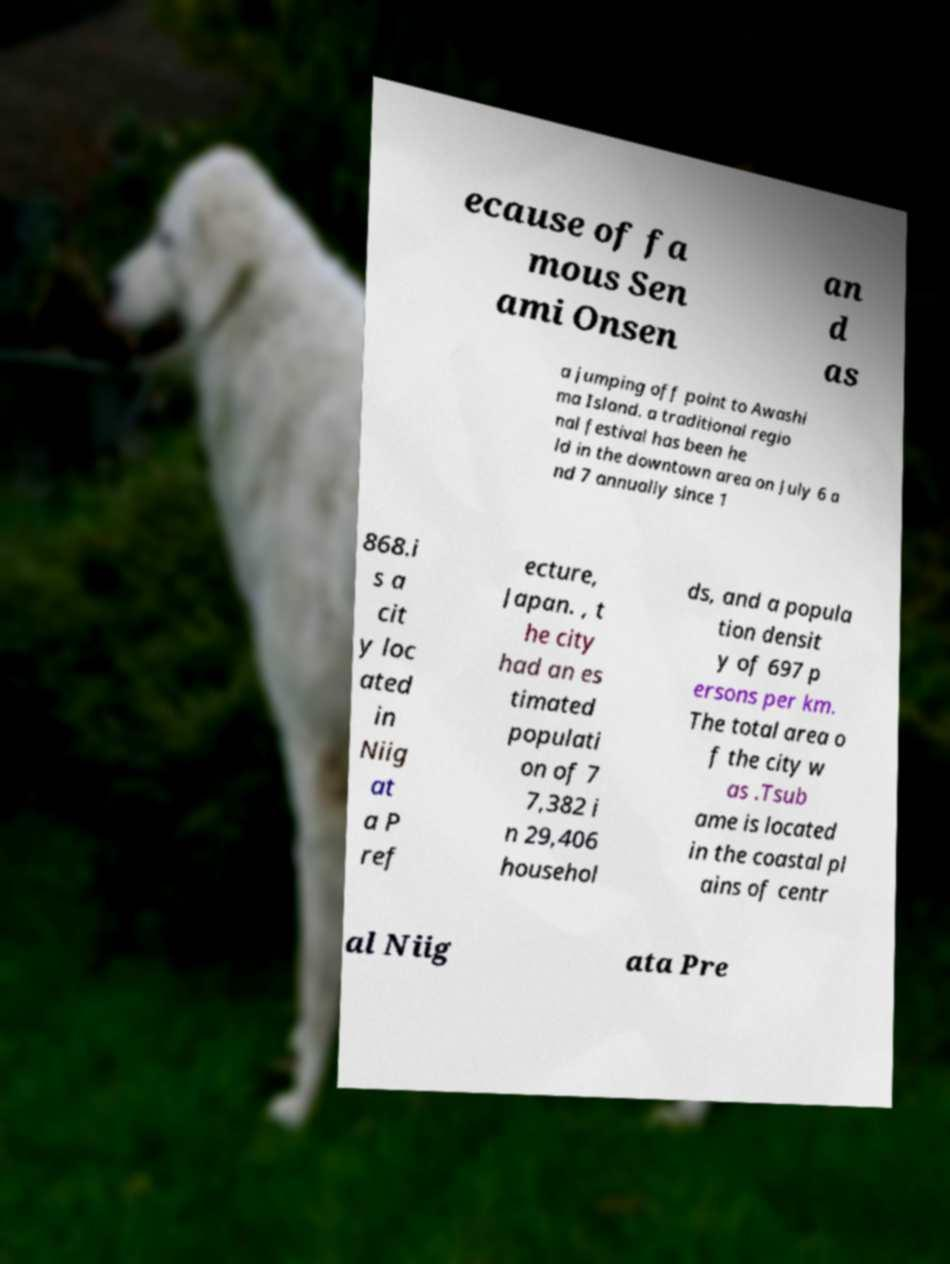Can you accurately transcribe the text from the provided image for me? ecause of fa mous Sen ami Onsen an d as a jumping off point to Awashi ma Island. a traditional regio nal festival has been he ld in the downtown area on July 6 a nd 7 annually since 1 868.i s a cit y loc ated in Niig at a P ref ecture, Japan. , t he city had an es timated populati on of 7 7,382 i n 29,406 househol ds, and a popula tion densit y of 697 p ersons per km. The total area o f the city w as .Tsub ame is located in the coastal pl ains of centr al Niig ata Pre 